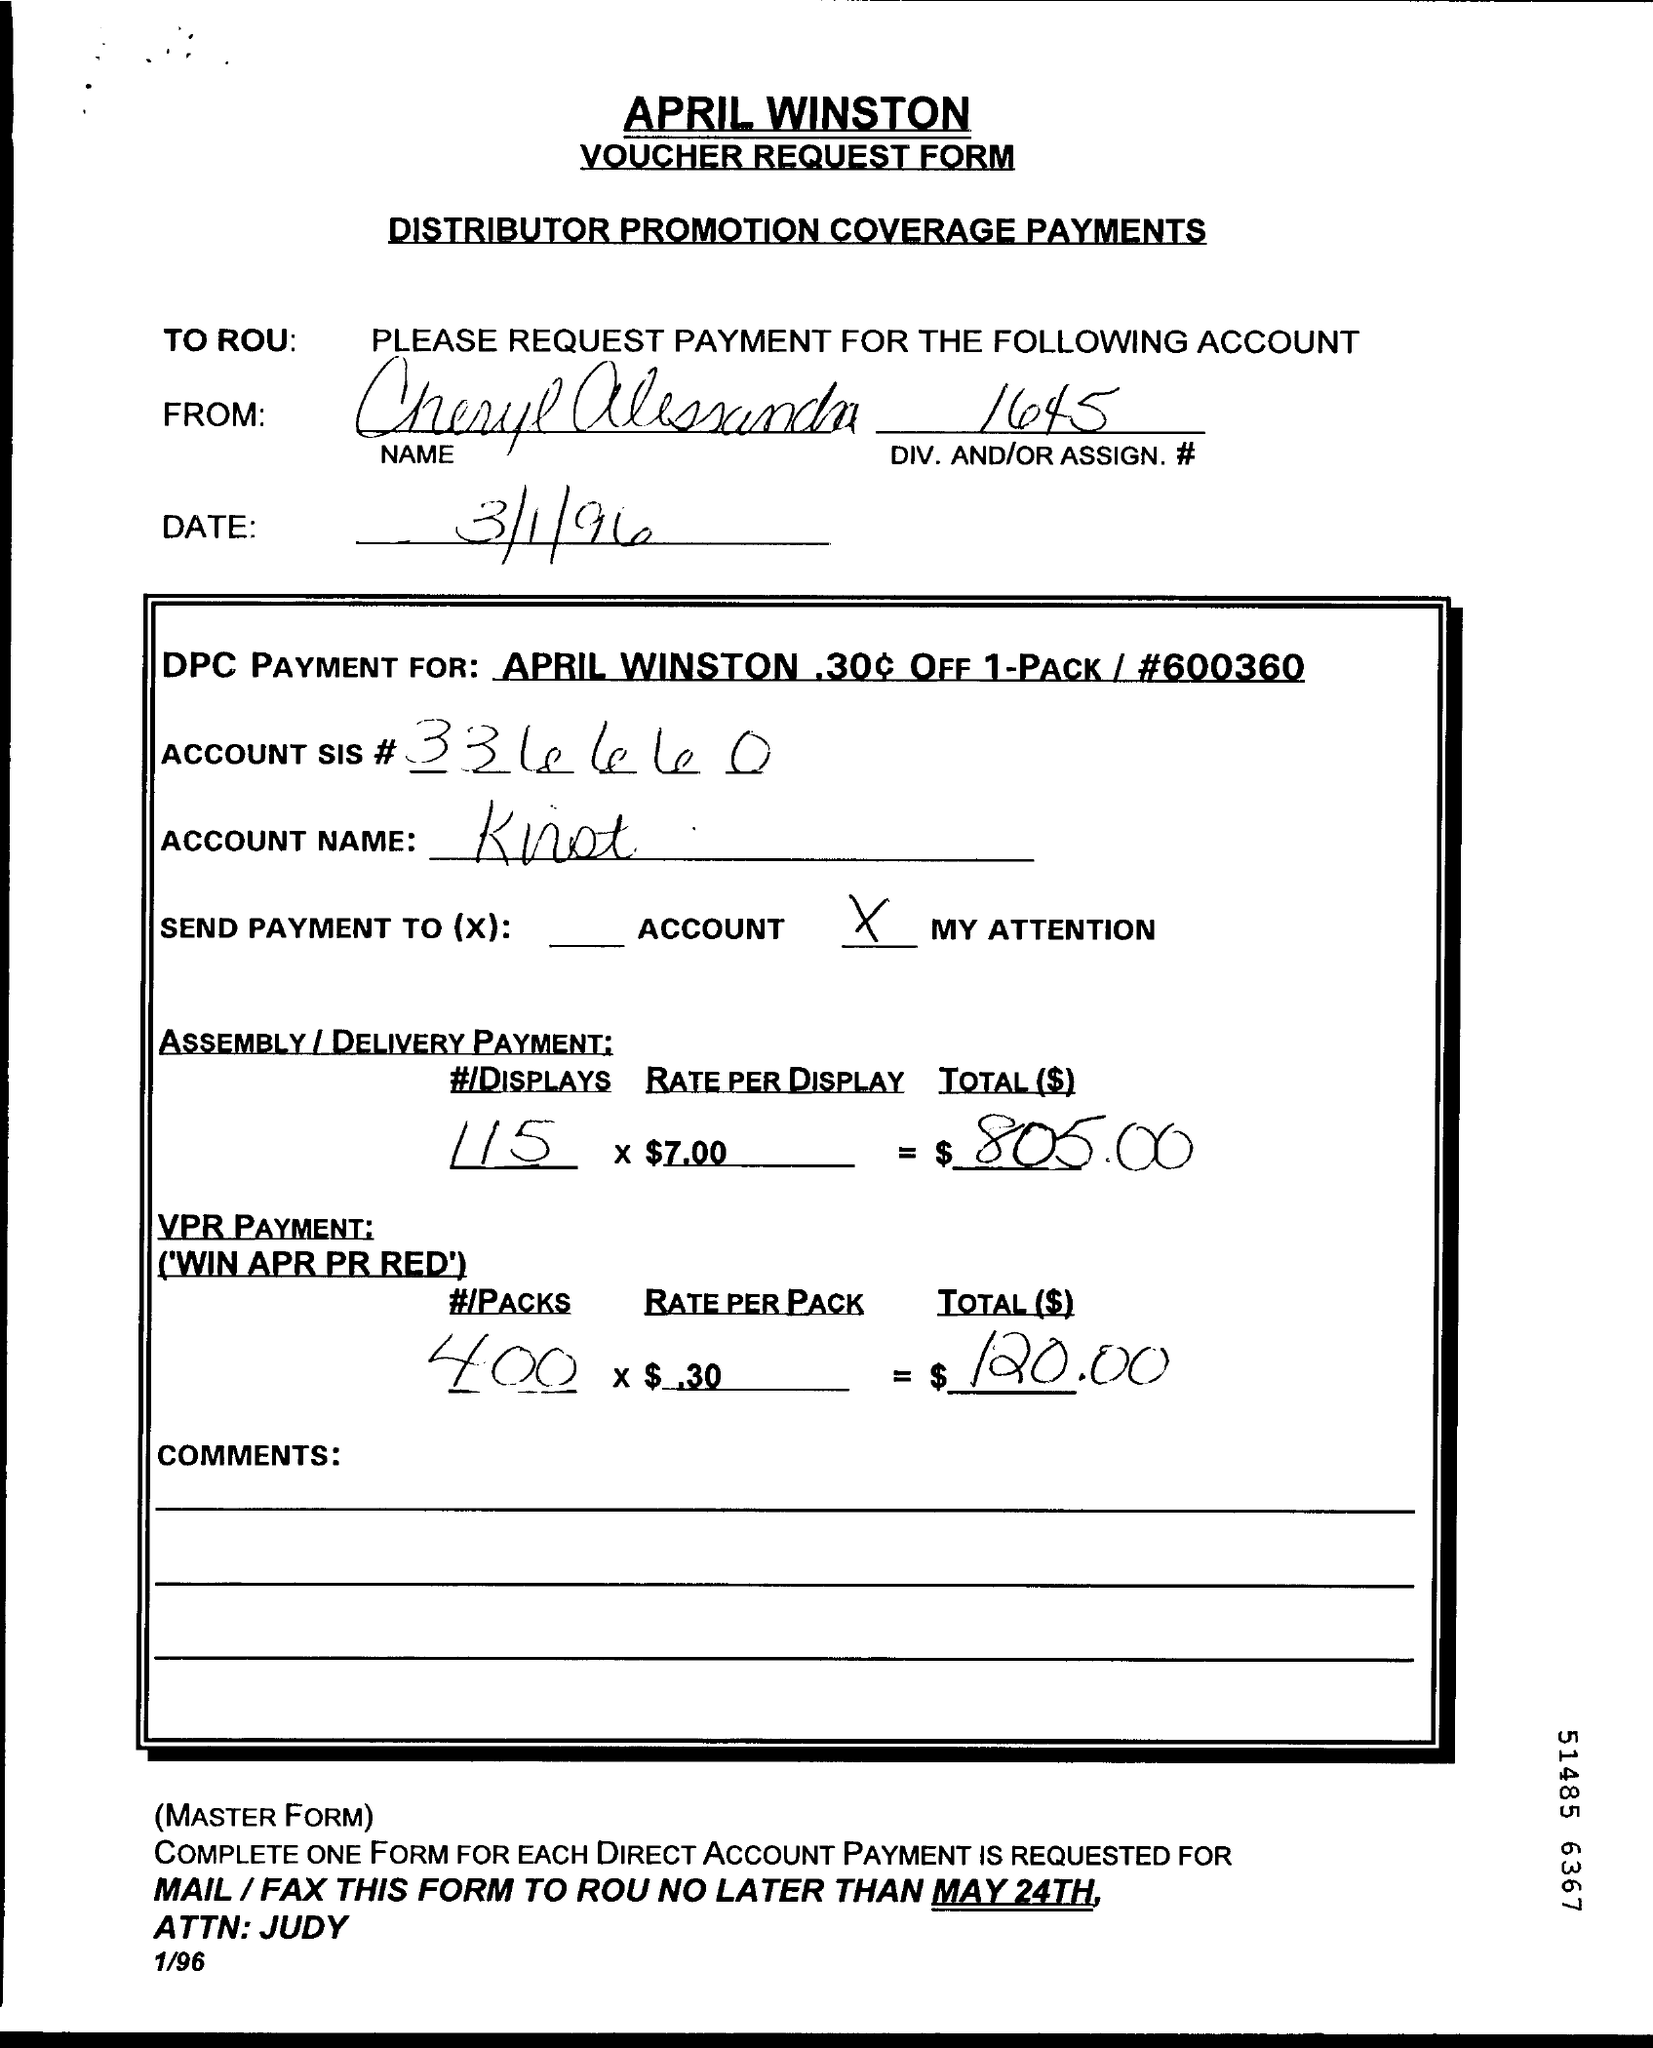When is the Memorandum dated on ?
Your answer should be compact. 3/1/96. What is the DIV.AND/OR ASSIGN Number ?
Offer a very short reply. 1645. 